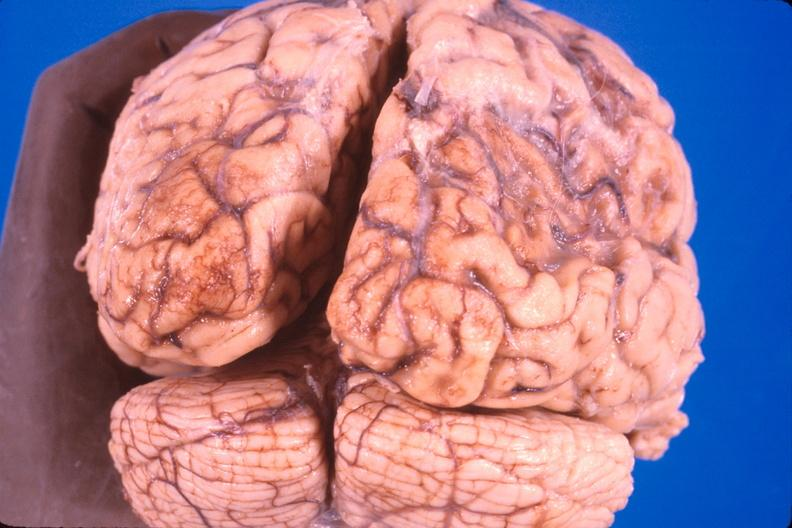what does this image show?
Answer the question using a single word or phrase. Brain 